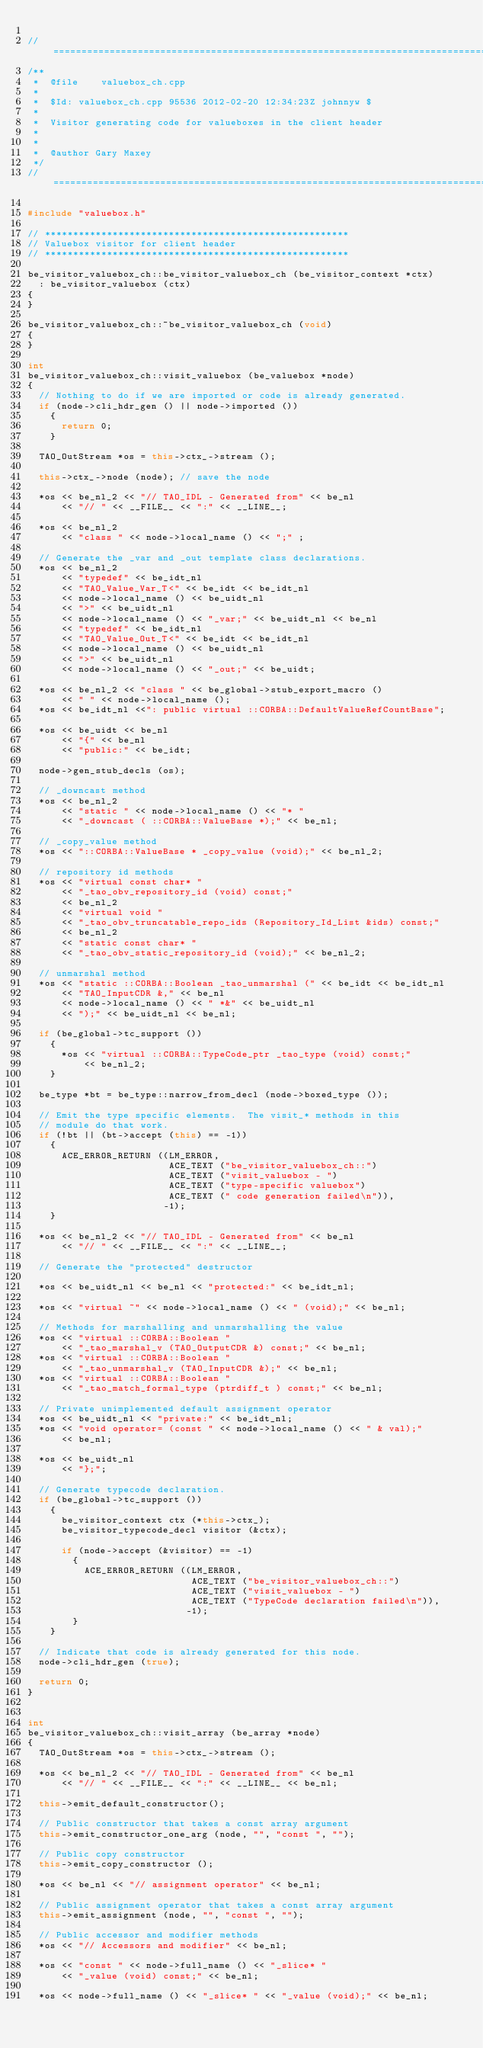<code> <loc_0><loc_0><loc_500><loc_500><_C++_>
//=============================================================================
/**
 *  @file    valuebox_ch.cpp
 *
 *  $Id: valuebox_ch.cpp 95536 2012-02-20 12:34:23Z johnnyw $
 *
 *  Visitor generating code for valueboxes in the client header
 *
 *
 *  @author Gary Maxey
 */
//=============================================================================

#include "valuebox.h"

// ******************************************************
// Valuebox visitor for client header
// ******************************************************

be_visitor_valuebox_ch::be_visitor_valuebox_ch (be_visitor_context *ctx)
  : be_visitor_valuebox (ctx)
{
}

be_visitor_valuebox_ch::~be_visitor_valuebox_ch (void)
{
}

int
be_visitor_valuebox_ch::visit_valuebox (be_valuebox *node)
{
  // Nothing to do if we are imported or code is already generated.
  if (node->cli_hdr_gen () || node->imported ())
    {
      return 0;
    }

  TAO_OutStream *os = this->ctx_->stream ();

  this->ctx_->node (node); // save the node

  *os << be_nl_2 << "// TAO_IDL - Generated from" << be_nl
      << "// " << __FILE__ << ":" << __LINE__;

  *os << be_nl_2
      << "class " << node->local_name () << ";" ;

  // Generate the _var and _out template class declarations.
  *os << be_nl_2
      << "typedef" << be_idt_nl
      << "TAO_Value_Var_T<" << be_idt << be_idt_nl
      << node->local_name () << be_uidt_nl
      << ">" << be_uidt_nl
      << node->local_name () << "_var;" << be_uidt_nl << be_nl
      << "typedef" << be_idt_nl
      << "TAO_Value_Out_T<" << be_idt << be_idt_nl
      << node->local_name () << be_uidt_nl
      << ">" << be_uidt_nl
      << node->local_name () << "_out;" << be_uidt;

  *os << be_nl_2 << "class " << be_global->stub_export_macro ()
      << " " << node->local_name ();
  *os << be_idt_nl <<": public virtual ::CORBA::DefaultValueRefCountBase";

  *os << be_uidt << be_nl
      << "{" << be_nl
      << "public:" << be_idt;

  node->gen_stub_decls (os);

  // _downcast method
  *os << be_nl_2
      << "static " << node->local_name () << "* "
      << "_downcast ( ::CORBA::ValueBase *);" << be_nl;

  // _copy_value method
  *os << "::CORBA::ValueBase * _copy_value (void);" << be_nl_2;

  // repository id methods
  *os << "virtual const char* "
      << "_tao_obv_repository_id (void) const;"
      << be_nl_2
      << "virtual void "
      << "_tao_obv_truncatable_repo_ids (Repository_Id_List &ids) const;"
      << be_nl_2
      << "static const char* "
      << "_tao_obv_static_repository_id (void);" << be_nl_2;

  // unmarshal method
  *os << "static ::CORBA::Boolean _tao_unmarshal (" << be_idt << be_idt_nl
      << "TAO_InputCDR &," << be_nl
      << node->local_name () << " *&" << be_uidt_nl
      << ");" << be_uidt_nl << be_nl;

  if (be_global->tc_support ())
    {
      *os << "virtual ::CORBA::TypeCode_ptr _tao_type (void) const;"
          << be_nl_2;
    }

  be_type *bt = be_type::narrow_from_decl (node->boxed_type ());

  // Emit the type specific elements.  The visit_* methods in this
  // module do that work.
  if (!bt || (bt->accept (this) == -1))
    {
      ACE_ERROR_RETURN ((LM_ERROR,
                         ACE_TEXT ("be_visitor_valuebox_ch::")
                         ACE_TEXT ("visit_valuebox - ")
                         ACE_TEXT ("type-specific valuebox")
                         ACE_TEXT (" code generation failed\n")),
                        -1);
    }

  *os << be_nl_2 << "// TAO_IDL - Generated from" << be_nl
      << "// " << __FILE__ << ":" << __LINE__;

  // Generate the "protected" destructor

  *os << be_uidt_nl << be_nl << "protected:" << be_idt_nl;

  *os << "virtual ~" << node->local_name () << " (void);" << be_nl;

  // Methods for marshalling and unmarshalling the value
  *os << "virtual ::CORBA::Boolean "
      << "_tao_marshal_v (TAO_OutputCDR &) const;" << be_nl;
  *os << "virtual ::CORBA::Boolean "
      << "_tao_unmarshal_v (TAO_InputCDR &);" << be_nl;
  *os << "virtual ::CORBA::Boolean "
      << "_tao_match_formal_type (ptrdiff_t ) const;" << be_nl;

  // Private unimplemented default assignment operator
  *os << be_uidt_nl << "private:" << be_idt_nl;
  *os << "void operator= (const " << node->local_name () << " & val);"
      << be_nl;

  *os << be_uidt_nl
      << "};";

  // Generate typecode declaration.
  if (be_global->tc_support ())
    {
      be_visitor_context ctx (*this->ctx_);
      be_visitor_typecode_decl visitor (&ctx);

      if (node->accept (&visitor) == -1)
        {
          ACE_ERROR_RETURN ((LM_ERROR,
                             ACE_TEXT ("be_visitor_valuebox_ch::")
                             ACE_TEXT ("visit_valuebox - ")
                             ACE_TEXT ("TypeCode declaration failed\n")),
                            -1);
        }
    }

  // Indicate that code is already generated for this node.
  node->cli_hdr_gen (true);

  return 0;
}


int
be_visitor_valuebox_ch::visit_array (be_array *node)
{
  TAO_OutStream *os = this->ctx_->stream ();

  *os << be_nl_2 << "// TAO_IDL - Generated from" << be_nl
      << "// " << __FILE__ << ":" << __LINE__ << be_nl;

  this->emit_default_constructor();

  // Public constructor that takes a const array argument
  this->emit_constructor_one_arg (node, "", "const ", "");

  // Public copy constructor
  this->emit_copy_constructor ();

  *os << be_nl << "// assignment operator" << be_nl;

  // Public assignment operator that takes a const array argument
  this->emit_assignment (node, "", "const ", "");

  // Public accessor and modifier methods
  *os << "// Accessors and modifier" << be_nl;

  *os << "const " << node->full_name () << "_slice* "
      << "_value (void) const;" << be_nl;

  *os << node->full_name () << "_slice* " << "_value (void);" << be_nl;
</code> 